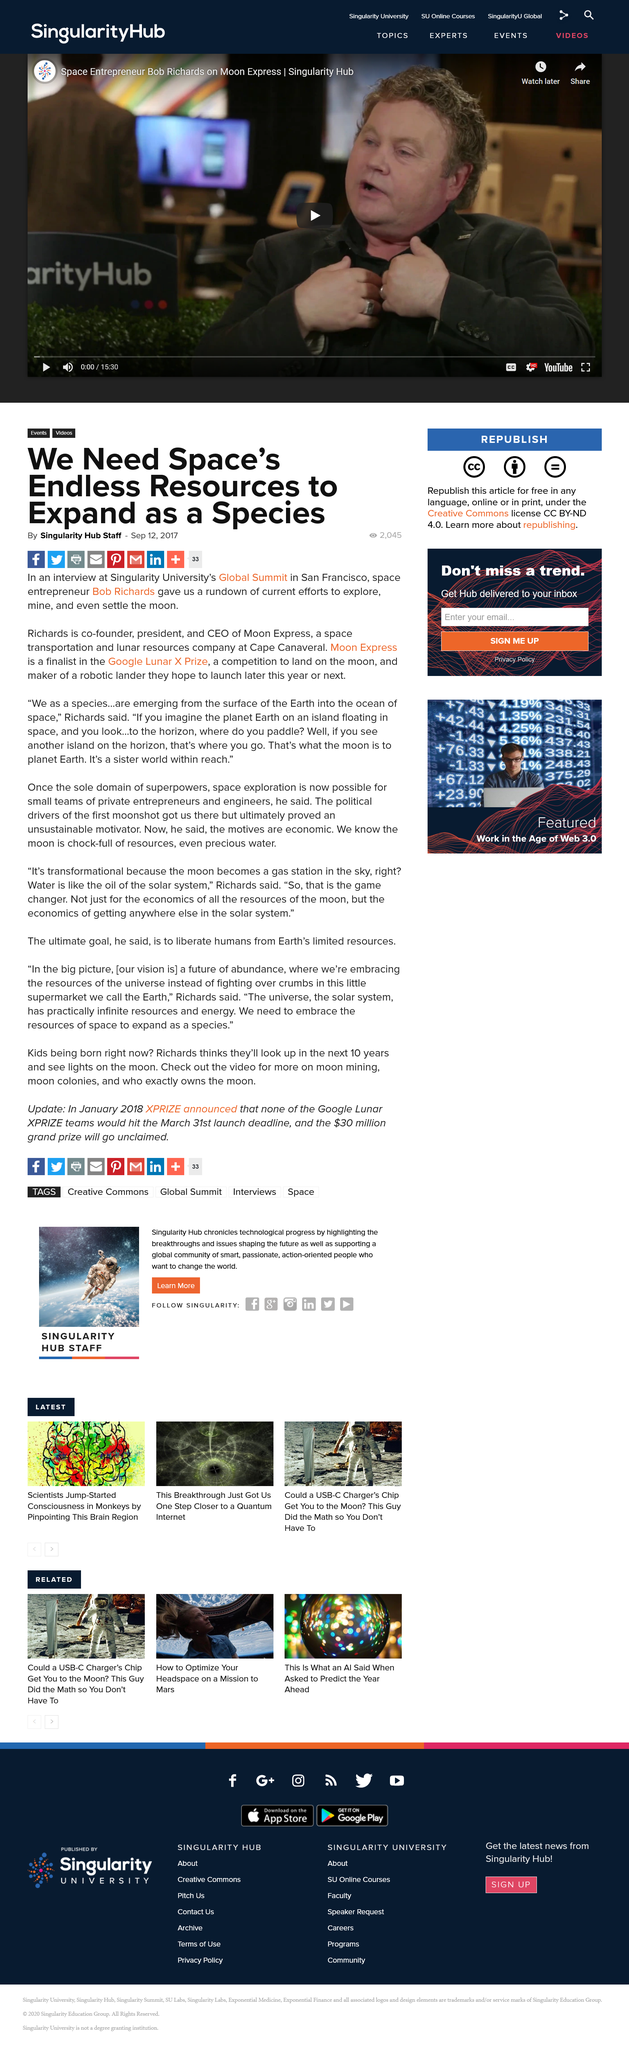Outline some significant characteristics in this image. This article is titled 'What is the title of this article? We Need Space's Endless Resources to Expand as a Species..' This article was created on September 12th, 2017. The article was created by Singularity Hub Staff. 